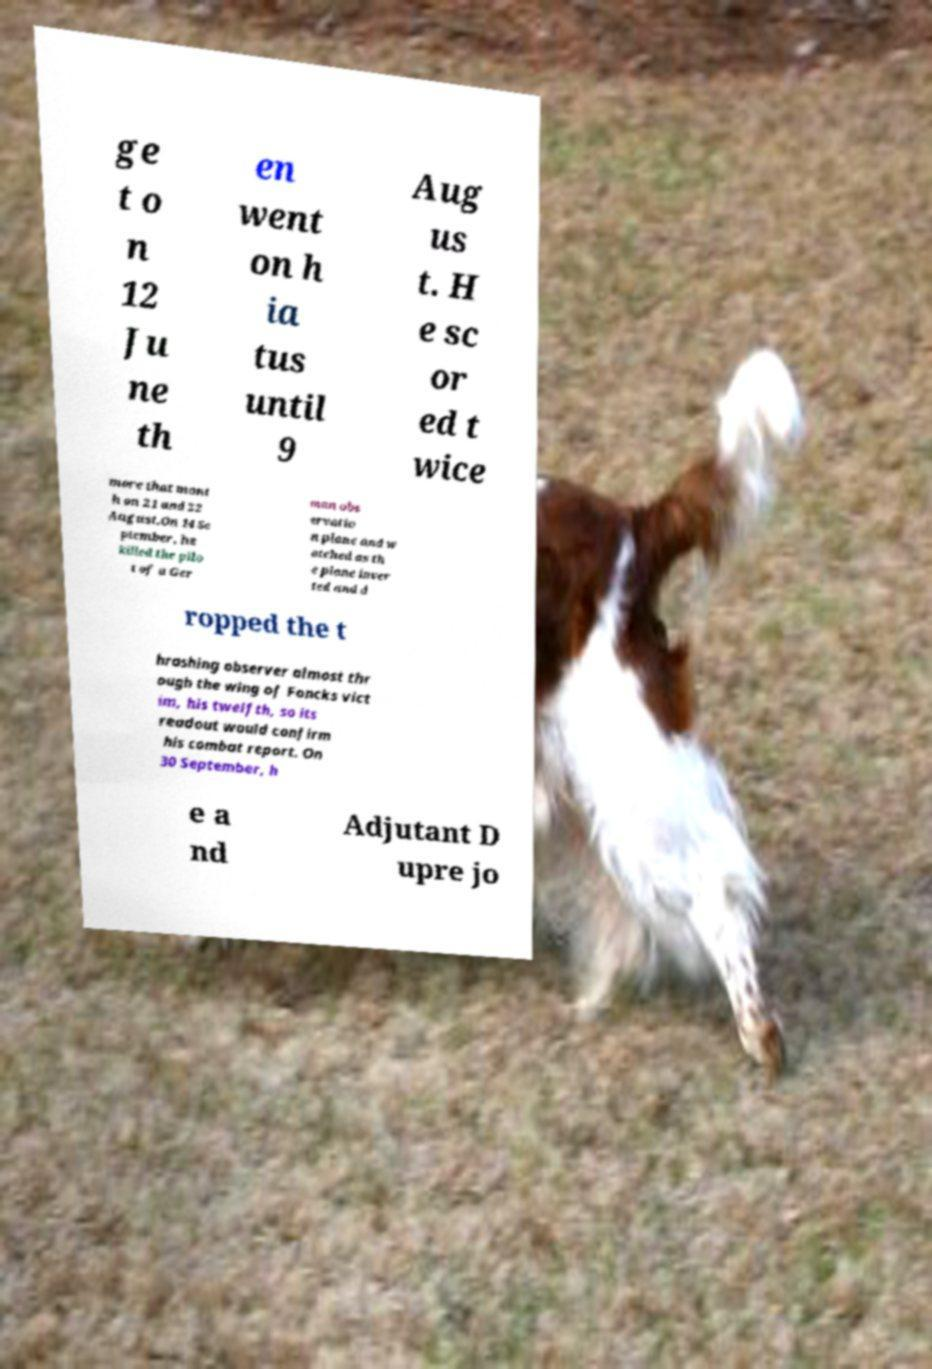For documentation purposes, I need the text within this image transcribed. Could you provide that? ge t o n 12 Ju ne th en went on h ia tus until 9 Aug us t. H e sc or ed t wice more that mont h on 21 and 22 August.On 14 Se ptember, he killed the pilo t of a Ger man obs ervatio n plane and w atched as th e plane inver ted and d ropped the t hrashing observer almost thr ough the wing of Foncks vict im, his twelfth, so its readout would confirm his combat report. On 30 September, h e a nd Adjutant D upre jo 